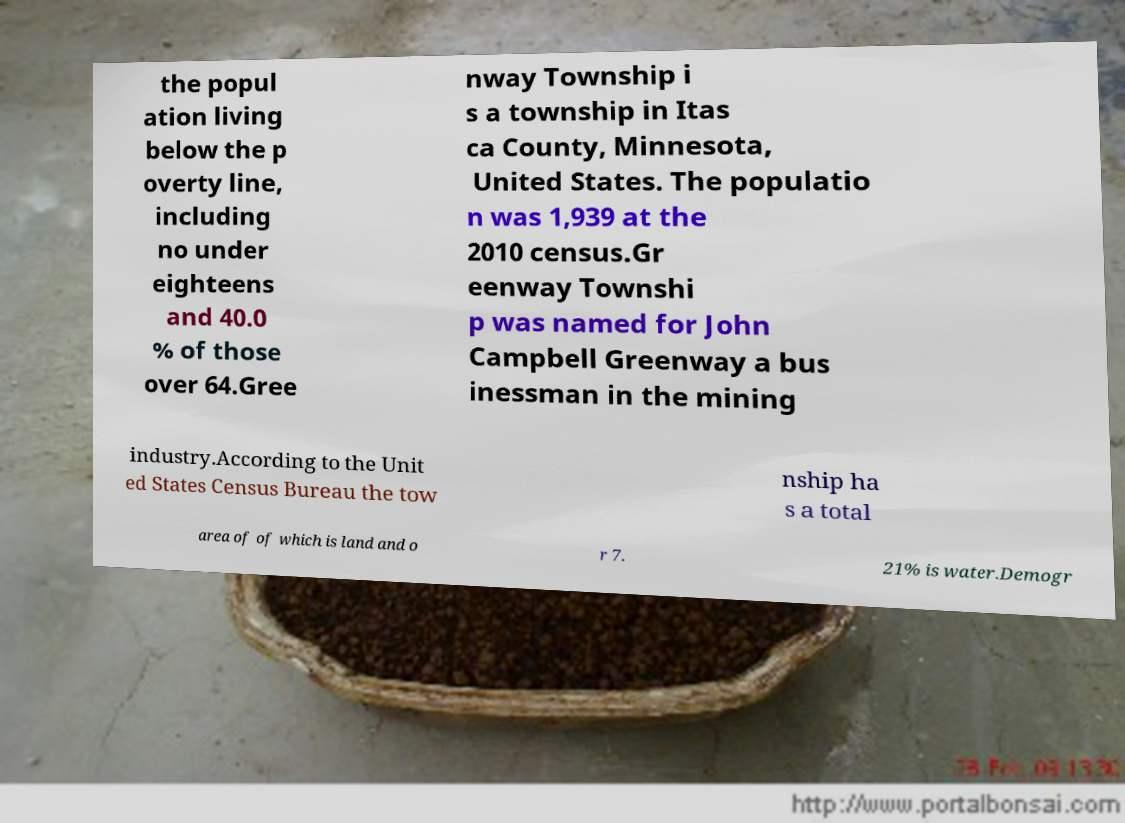There's text embedded in this image that I need extracted. Can you transcribe it verbatim? the popul ation living below the p overty line, including no under eighteens and 40.0 % of those over 64.Gree nway Township i s a township in Itas ca County, Minnesota, United States. The populatio n was 1,939 at the 2010 census.Gr eenway Townshi p was named for John Campbell Greenway a bus inessman in the mining industry.According to the Unit ed States Census Bureau the tow nship ha s a total area of of which is land and o r 7. 21% is water.Demogr 